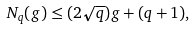Convert formula to latex. <formula><loc_0><loc_0><loc_500><loc_500>N _ { q } ( g ) \leq ( 2 \sqrt { q } ) g + ( q + 1 ) ,</formula> 